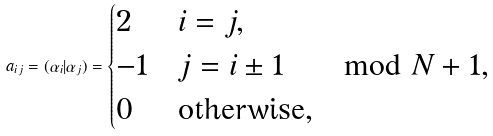Convert formula to latex. <formula><loc_0><loc_0><loc_500><loc_500>a _ { i j } = ( \alpha _ { i } | \alpha _ { j } ) = \begin{cases} 2 & i = j , \\ - 1 & j = i \pm 1 \quad \mod N + 1 , \\ 0 & \text {otherwise} , \end{cases}</formula> 